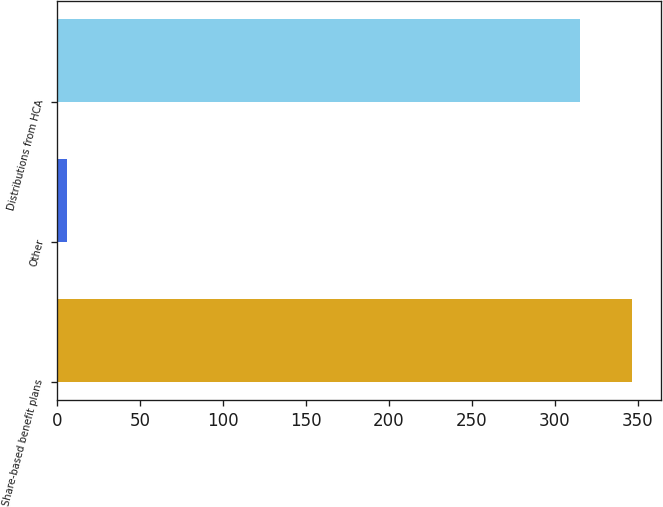Convert chart. <chart><loc_0><loc_0><loc_500><loc_500><bar_chart><fcel>Share-based benefit plans<fcel>Other<fcel>Distributions from HCA<nl><fcel>346.5<fcel>6<fcel>315<nl></chart> 